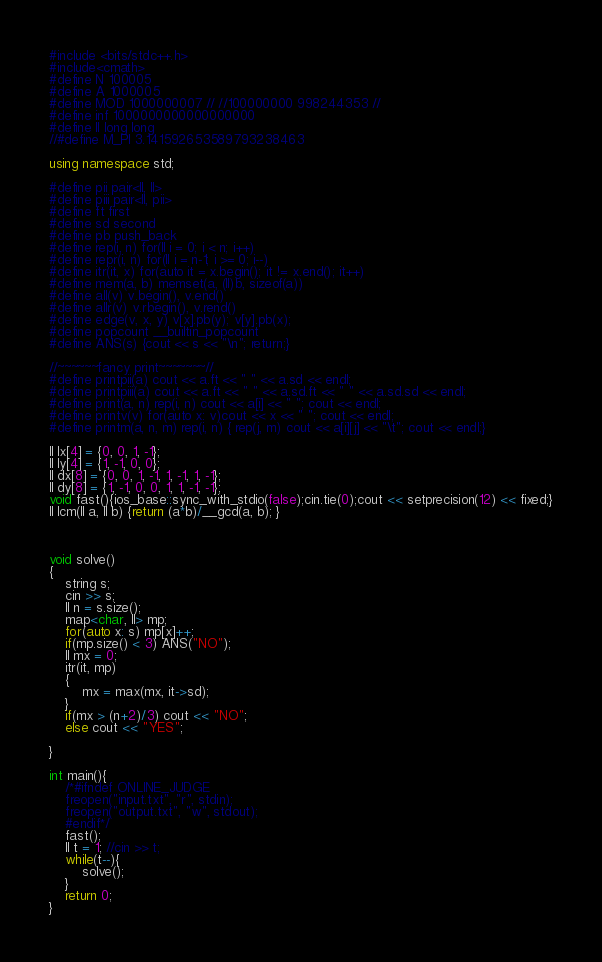<code> <loc_0><loc_0><loc_500><loc_500><_C++_>#include <bits/stdc++.h>
#include<cmath>
#define N 100005
#define A 1000005
#define MOD 1000000007 // //100000000 998244353 //
#define inf 1000000000000000000
#define ll long long
//#define M_PI 3.141592653589793238463

using namespace std;

#define pii pair<ll, ll>
#define piii pair<ll, pii>
#define ft first
#define sd second
#define pb push_back
#define rep(i, n) for(ll i = 0; i < n; i++)
#define repr(i, n) for(ll i = n-1; i >= 0; i--)
#define itr(it, x) for(auto it = x.begin(); it != x.end(); it++)
#define mem(a, b) memset(a, (ll)b, sizeof(a))
#define all(v) v.begin(), v.end()
#define allr(v) v.rbegin(), v.rend()
#define edge(v, x, y) v[x].pb(y); v[y].pb(x);
#define popcount __builtin_popcount
#define ANS(s) {cout << s << "\n"; return;}

//~~~~~~fancy print~~~~~~~//
#define printpii(a) cout << a.ft << " " << a.sd << endl;
#define printpiii(a) cout << a.ft << " " << a.sd.ft << " " << a.sd.sd << endl;
#define print(a, n) rep(i, n) cout << a[i] << " "; cout << endl;
#define printv(v) for(auto x: v)cout << x << " "; cout << endl;
#define printm(a, n, m) rep(i, n) { rep(j, m) cout << a[i][j] << "\t"; cout << endl;}

ll lx[4] = {0, 0, 1, -1};
ll ly[4] = {1, -1, 0, 0};
ll dx[8] = {0, 0, 1, -1, 1, -1, 1, -1};
ll dy[8] = {1, -1, 0, 0, 1, 1, -1, -1};
void fast(){ios_base::sync_with_stdio(false);cin.tie(0);cout << setprecision(12) << fixed;}
ll lcm(ll a, ll b) {return (a*b)/__gcd(a, b); }



void solve()
{
    string s;
    cin >> s;
    ll n = s.size();
    map<char, ll> mp;
    for(auto x: s) mp[x]++;
    if(mp.size() < 3) ANS("NO");
    ll mx = 0;
    itr(it, mp)
    {
        mx = max(mx, it->sd);
    }
    if(mx > (n+2)/3) cout << "NO";
    else cout << "YES";

}

int main(){
    /*#ifndef ONLINE_JUDGE
    freopen("input.txt", "r", stdin);
    freopen("output.txt", "w", stdout);
    #endif*/
    fast();
    ll t = 1; //cin >> t;
    while(t--){
        solve();
    }
    return 0;
}
</code> 